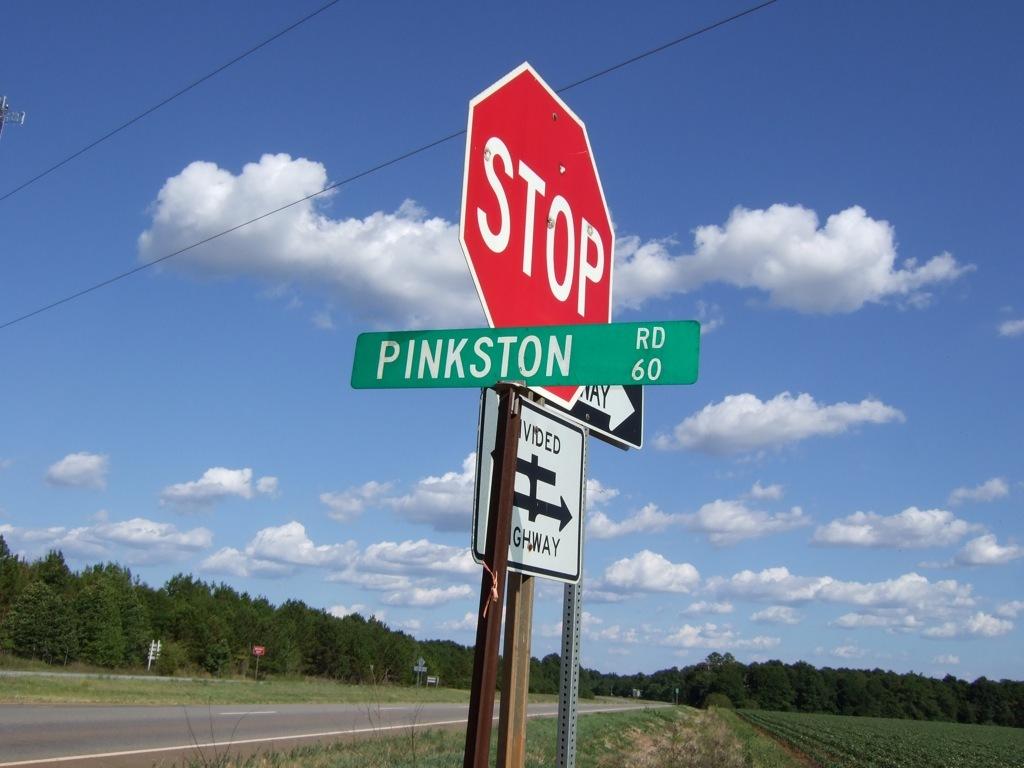What road is this?
Keep it short and to the point. Pinkston. What is the red sign telling you to do?
Your answer should be compact. Stop. 